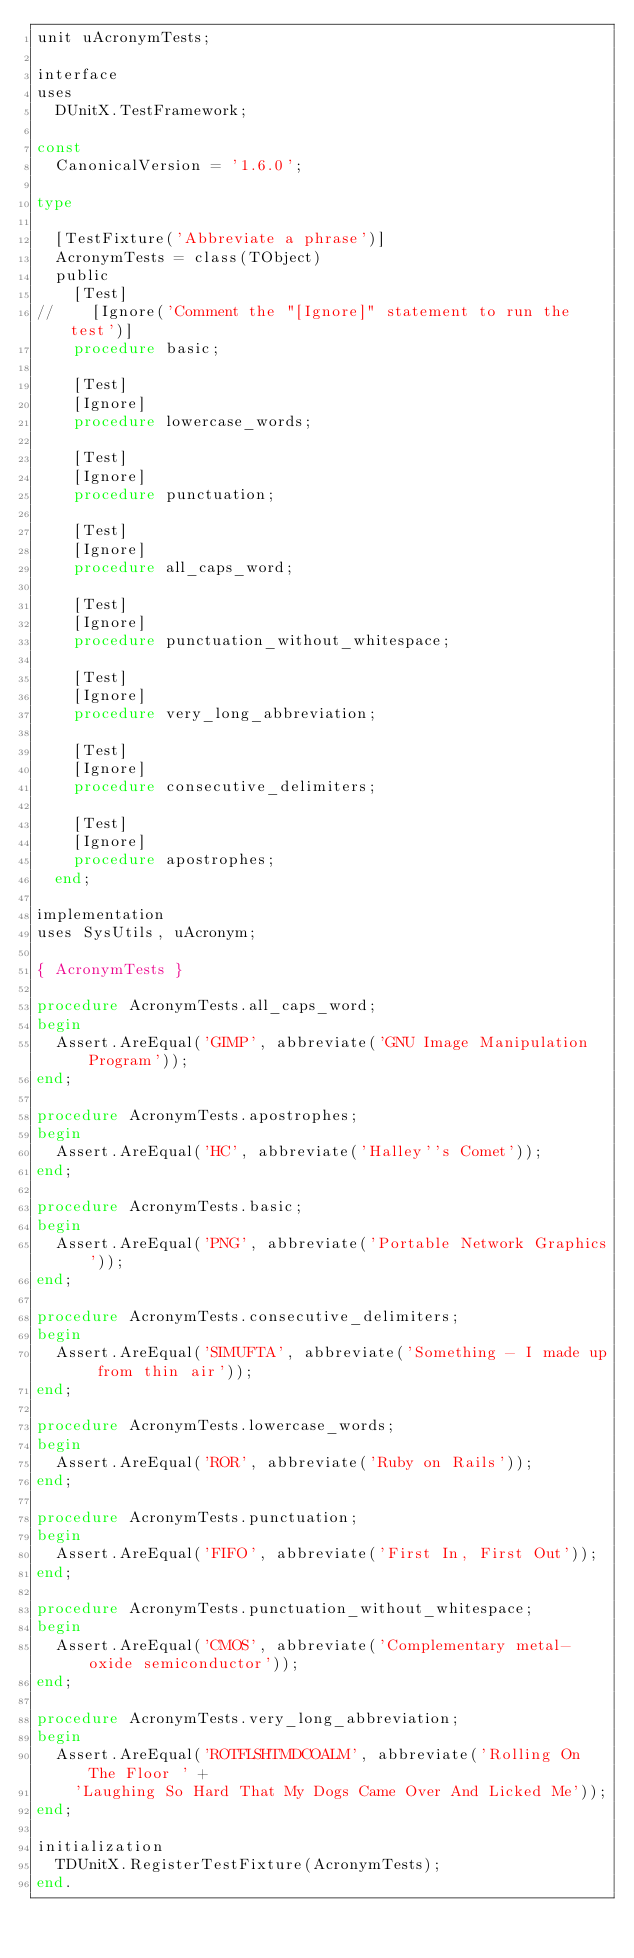<code> <loc_0><loc_0><loc_500><loc_500><_Pascal_>unit uAcronymTests;

interface
uses
  DUnitX.TestFramework;

const
  CanonicalVersion = '1.6.0';

type

  [TestFixture('Abbreviate a phrase')]
  AcronymTests = class(TObject)
  public
    [Test]
//    [Ignore('Comment the "[Ignore]" statement to run the test')]
    procedure basic;

    [Test]
    [Ignore]
    procedure lowercase_words;

    [Test]
    [Ignore]
    procedure punctuation;

    [Test]
    [Ignore]
    procedure all_caps_word;

    [Test]
    [Ignore]
    procedure punctuation_without_whitespace;

    [Test]
    [Ignore]
    procedure very_long_abbreviation;

    [Test]
    [Ignore]
    procedure consecutive_delimiters;

    [Test]
    [Ignore]
    procedure apostrophes;
  end;

implementation
uses SysUtils, uAcronym;

{ AcronymTests }

procedure AcronymTests.all_caps_word;
begin
  Assert.AreEqual('GIMP', abbreviate('GNU Image Manipulation Program'));
end;

procedure AcronymTests.apostrophes;
begin
  Assert.AreEqual('HC', abbreviate('Halley''s Comet'));
end;

procedure AcronymTests.basic;
begin
  Assert.AreEqual('PNG', abbreviate('Portable Network Graphics'));
end;

procedure AcronymTests.consecutive_delimiters;
begin
  Assert.AreEqual('SIMUFTA', abbreviate('Something - I made up from thin air'));
end;

procedure AcronymTests.lowercase_words;
begin
  Assert.AreEqual('ROR', abbreviate('Ruby on Rails'));
end;

procedure AcronymTests.punctuation;
begin
  Assert.AreEqual('FIFO', abbreviate('First In, First Out'));
end;

procedure AcronymTests.punctuation_without_whitespace;
begin
  Assert.AreEqual('CMOS', abbreviate('Complementary metal-oxide semiconductor'));
end;

procedure AcronymTests.very_long_abbreviation;
begin
  Assert.AreEqual('ROTFLSHTMDCOALM', abbreviate('Rolling On The Floor ' +
    'Laughing So Hard That My Dogs Came Over And Licked Me'));
end;

initialization
  TDUnitX.RegisterTestFixture(AcronymTests);
end.
</code> 